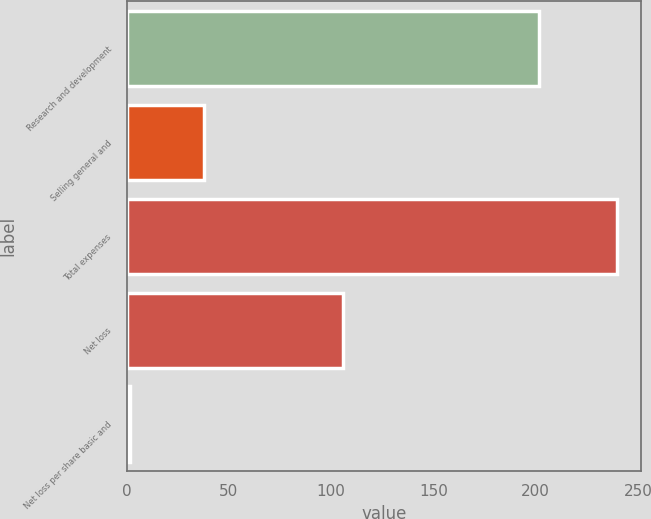Convert chart to OTSL. <chart><loc_0><loc_0><loc_500><loc_500><bar_chart><fcel>Research and development<fcel>Selling general and<fcel>Total expenses<fcel>Net loss<fcel>Net loss per share basic and<nl><fcel>201.6<fcel>37.9<fcel>239.5<fcel>105.6<fcel>1.59<nl></chart> 